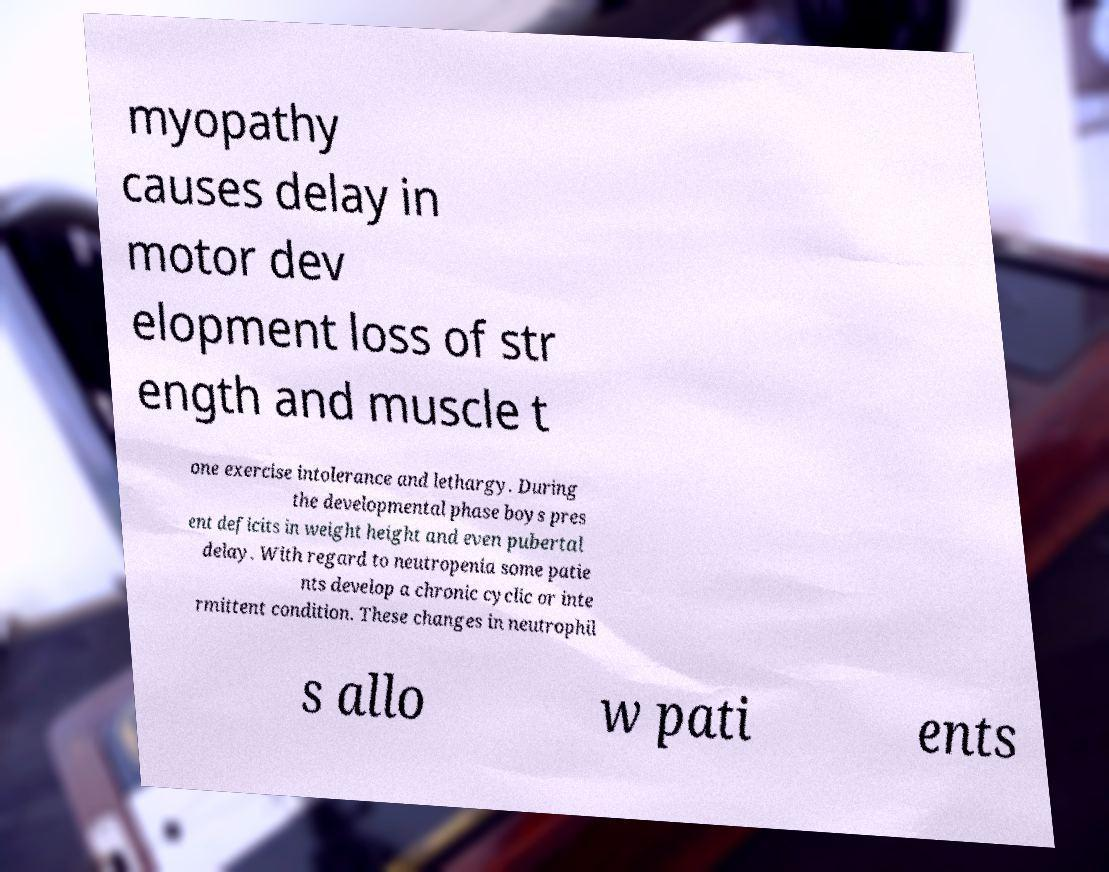Can you accurately transcribe the text from the provided image for me? myopathy causes delay in motor dev elopment loss of str ength and muscle t one exercise intolerance and lethargy. During the developmental phase boys pres ent deficits in weight height and even pubertal delay. With regard to neutropenia some patie nts develop a chronic cyclic or inte rmittent condition. These changes in neutrophil s allo w pati ents 